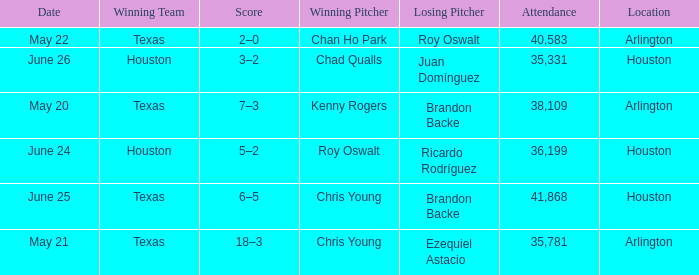Which location has a date of may 21? Arlington. 